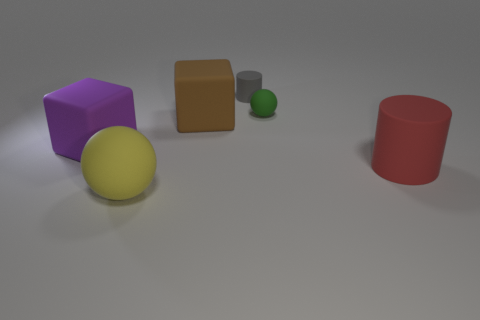Add 3 large red cylinders. How many objects exist? 9 Subtract all balls. How many objects are left? 4 Subtract all gray matte cylinders. Subtract all big yellow matte balls. How many objects are left? 4 Add 2 cubes. How many cubes are left? 4 Add 4 big rubber objects. How many big rubber objects exist? 8 Subtract 1 brown cubes. How many objects are left? 5 